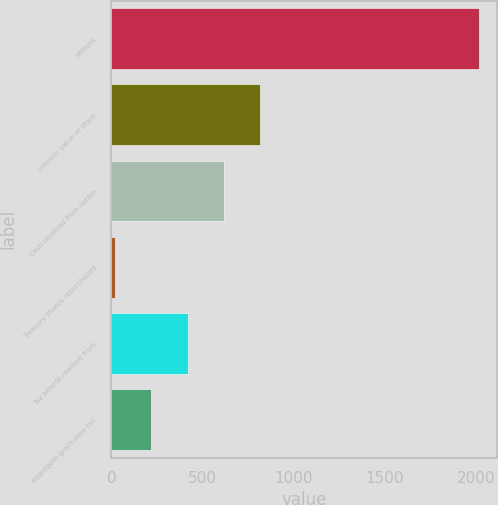<chart> <loc_0><loc_0><loc_500><loc_500><bar_chart><fcel>Millions<fcel>Intrinsic value of stock<fcel>Cash received from option<fcel>Treasury shares repurchased<fcel>Tax benefit realized from<fcel>Aggregate grant-date fair<nl><fcel>2017<fcel>817.6<fcel>617.7<fcel>18<fcel>417.8<fcel>217.9<nl></chart> 